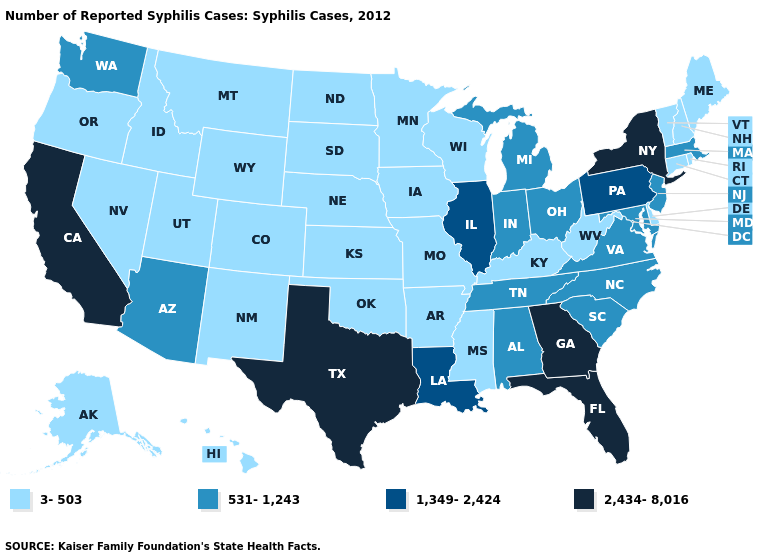Name the states that have a value in the range 2,434-8,016?
Concise answer only. California, Florida, Georgia, New York, Texas. What is the value of Hawaii?
Give a very brief answer. 3-503. Name the states that have a value in the range 531-1,243?
Write a very short answer. Alabama, Arizona, Indiana, Maryland, Massachusetts, Michigan, New Jersey, North Carolina, Ohio, South Carolina, Tennessee, Virginia, Washington. Name the states that have a value in the range 531-1,243?
Quick response, please. Alabama, Arizona, Indiana, Maryland, Massachusetts, Michigan, New Jersey, North Carolina, Ohio, South Carolina, Tennessee, Virginia, Washington. What is the highest value in the USA?
Quick response, please. 2,434-8,016. Name the states that have a value in the range 531-1,243?
Give a very brief answer. Alabama, Arizona, Indiana, Maryland, Massachusetts, Michigan, New Jersey, North Carolina, Ohio, South Carolina, Tennessee, Virginia, Washington. Among the states that border Tennessee , does Arkansas have the highest value?
Short answer required. No. What is the value of Utah?
Short answer required. 3-503. Does Ohio have the highest value in the USA?
Quick response, please. No. What is the value of Tennessee?
Give a very brief answer. 531-1,243. Name the states that have a value in the range 1,349-2,424?
Short answer required. Illinois, Louisiana, Pennsylvania. What is the value of California?
Answer briefly. 2,434-8,016. Name the states that have a value in the range 2,434-8,016?
Be succinct. California, Florida, Georgia, New York, Texas. What is the lowest value in the MidWest?
Quick response, please. 3-503. Among the states that border New Mexico , does Texas have the highest value?
Answer briefly. Yes. 